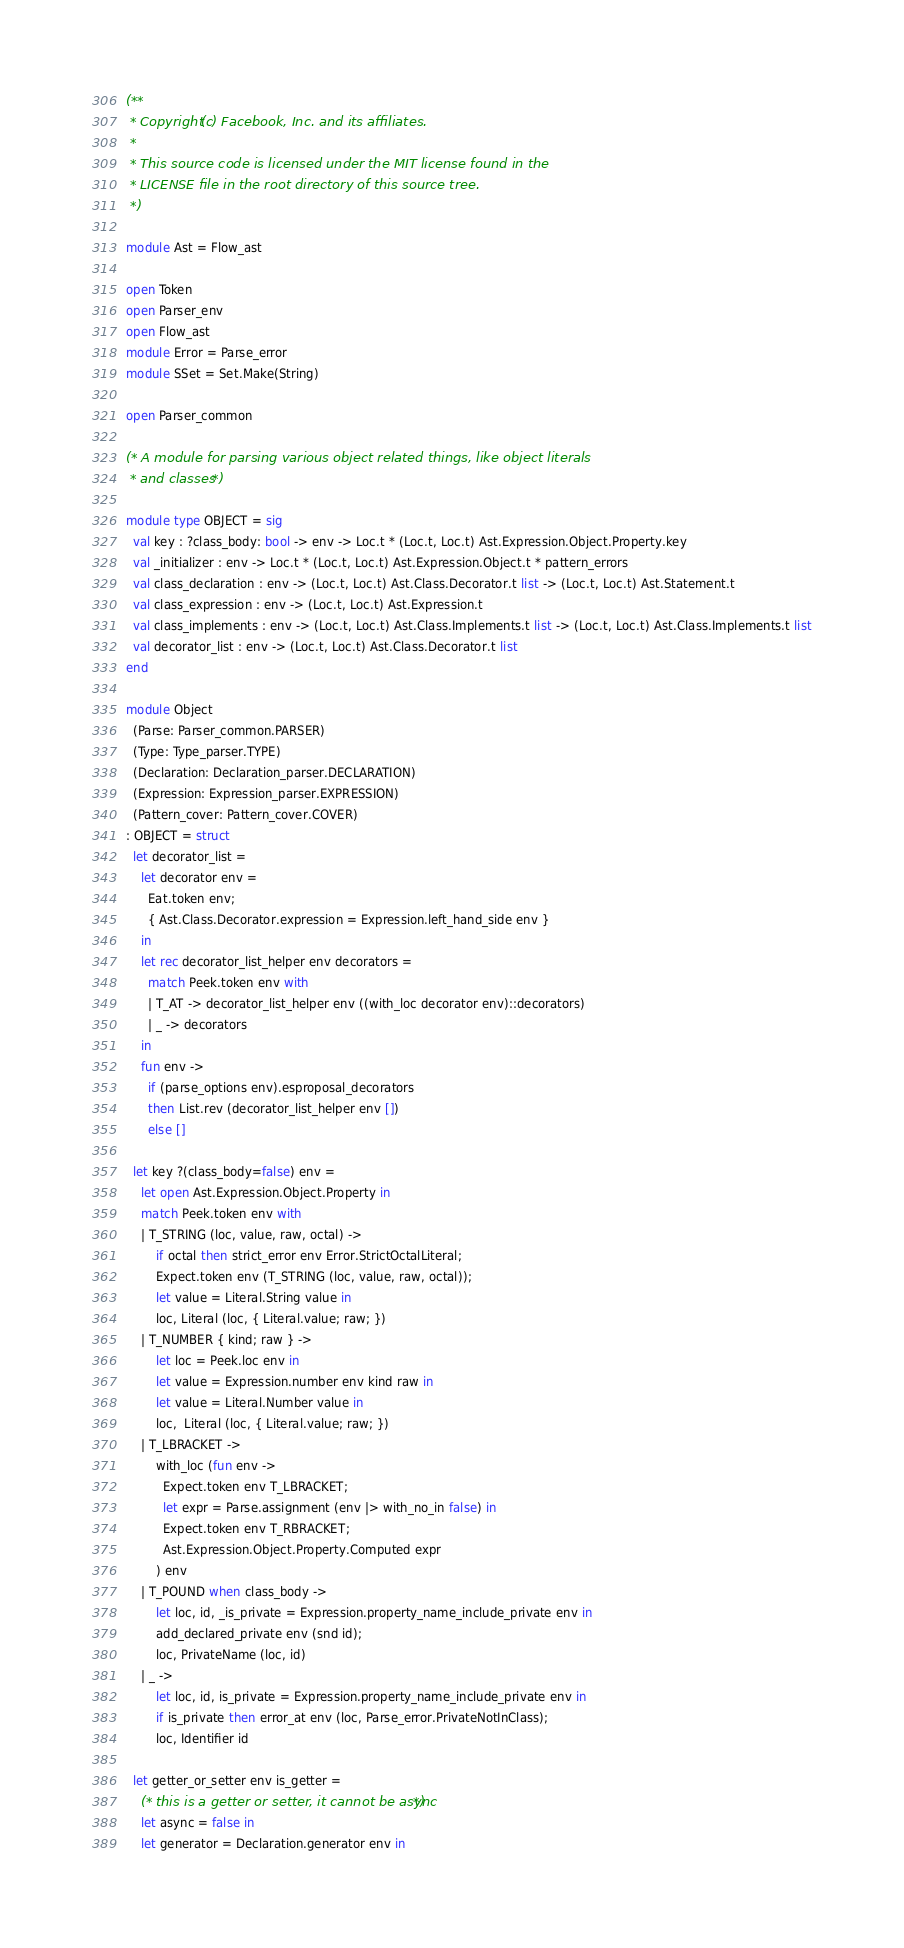<code> <loc_0><loc_0><loc_500><loc_500><_OCaml_>(**
 * Copyright (c) Facebook, Inc. and its affiliates.
 *
 * This source code is licensed under the MIT license found in the
 * LICENSE file in the root directory of this source tree.
 *)

module Ast = Flow_ast

open Token
open Parser_env
open Flow_ast
module Error = Parse_error
module SSet = Set.Make(String)

open Parser_common

(* A module for parsing various object related things, like object literals
 * and classes *)

module type OBJECT = sig
  val key : ?class_body: bool -> env -> Loc.t * (Loc.t, Loc.t) Ast.Expression.Object.Property.key
  val _initializer : env -> Loc.t * (Loc.t, Loc.t) Ast.Expression.Object.t * pattern_errors
  val class_declaration : env -> (Loc.t, Loc.t) Ast.Class.Decorator.t list -> (Loc.t, Loc.t) Ast.Statement.t
  val class_expression : env -> (Loc.t, Loc.t) Ast.Expression.t
  val class_implements : env -> (Loc.t, Loc.t) Ast.Class.Implements.t list -> (Loc.t, Loc.t) Ast.Class.Implements.t list
  val decorator_list : env -> (Loc.t, Loc.t) Ast.Class.Decorator.t list
end

module Object
  (Parse: Parser_common.PARSER)
  (Type: Type_parser.TYPE)
  (Declaration: Declaration_parser.DECLARATION)
  (Expression: Expression_parser.EXPRESSION)
  (Pattern_cover: Pattern_cover.COVER)
: OBJECT = struct
  let decorator_list =
    let decorator env =
      Eat.token env;
      { Ast.Class.Decorator.expression = Expression.left_hand_side env }
    in
    let rec decorator_list_helper env decorators =
      match Peek.token env with
      | T_AT -> decorator_list_helper env ((with_loc decorator env)::decorators)
      | _ -> decorators
    in
    fun env ->
      if (parse_options env).esproposal_decorators
      then List.rev (decorator_list_helper env [])
      else []

  let key ?(class_body=false) env =
    let open Ast.Expression.Object.Property in
    match Peek.token env with
    | T_STRING (loc, value, raw, octal) ->
        if octal then strict_error env Error.StrictOctalLiteral;
        Expect.token env (T_STRING (loc, value, raw, octal));
        let value = Literal.String value in
        loc, Literal (loc, { Literal.value; raw; })
    | T_NUMBER { kind; raw } ->
        let loc = Peek.loc env in
        let value = Expression.number env kind raw in
        let value = Literal.Number value in
        loc,  Literal (loc, { Literal.value; raw; })
    | T_LBRACKET ->
        with_loc (fun env ->
          Expect.token env T_LBRACKET;
          let expr = Parse.assignment (env |> with_no_in false) in
          Expect.token env T_RBRACKET;
          Ast.Expression.Object.Property.Computed expr
        ) env
    | T_POUND when class_body ->
        let loc, id, _is_private = Expression.property_name_include_private env in
        add_declared_private env (snd id);
        loc, PrivateName (loc, id)
    | _ ->
        let loc, id, is_private = Expression.property_name_include_private env in
        if is_private then error_at env (loc, Parse_error.PrivateNotInClass);
        loc, Identifier id

  let getter_or_setter env is_getter =
    (* this is a getter or setter, it cannot be async *)
    let async = false in
    let generator = Declaration.generator env in</code> 